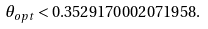Convert formula to latex. <formula><loc_0><loc_0><loc_500><loc_500>\theta _ { o p t } < 0 . 3 5 2 9 1 7 0 0 0 2 0 7 1 9 5 8 .</formula> 